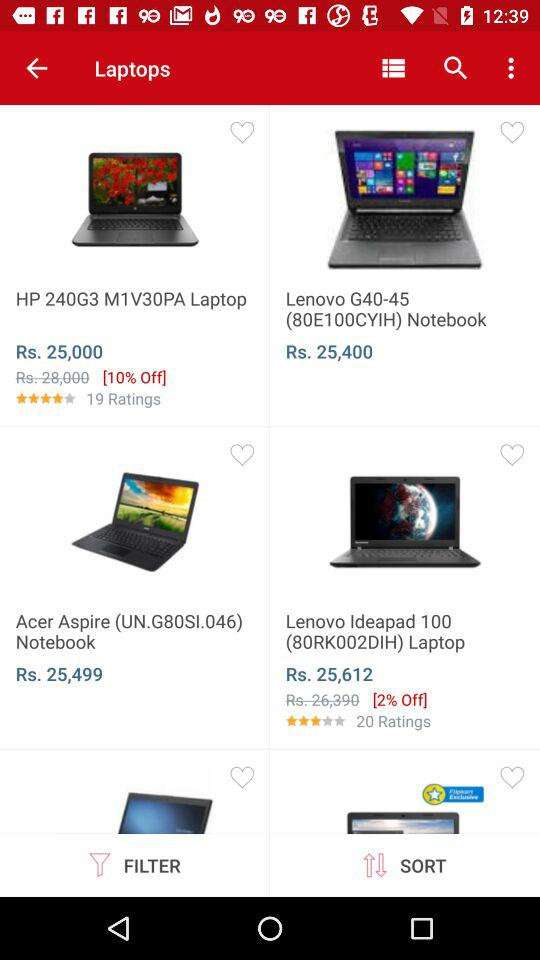What is the discounted price of a "Lenovo Ideapad" laptop? The discounted price of a "Lenovo Ideapad" laptop is Rs 25,612. 